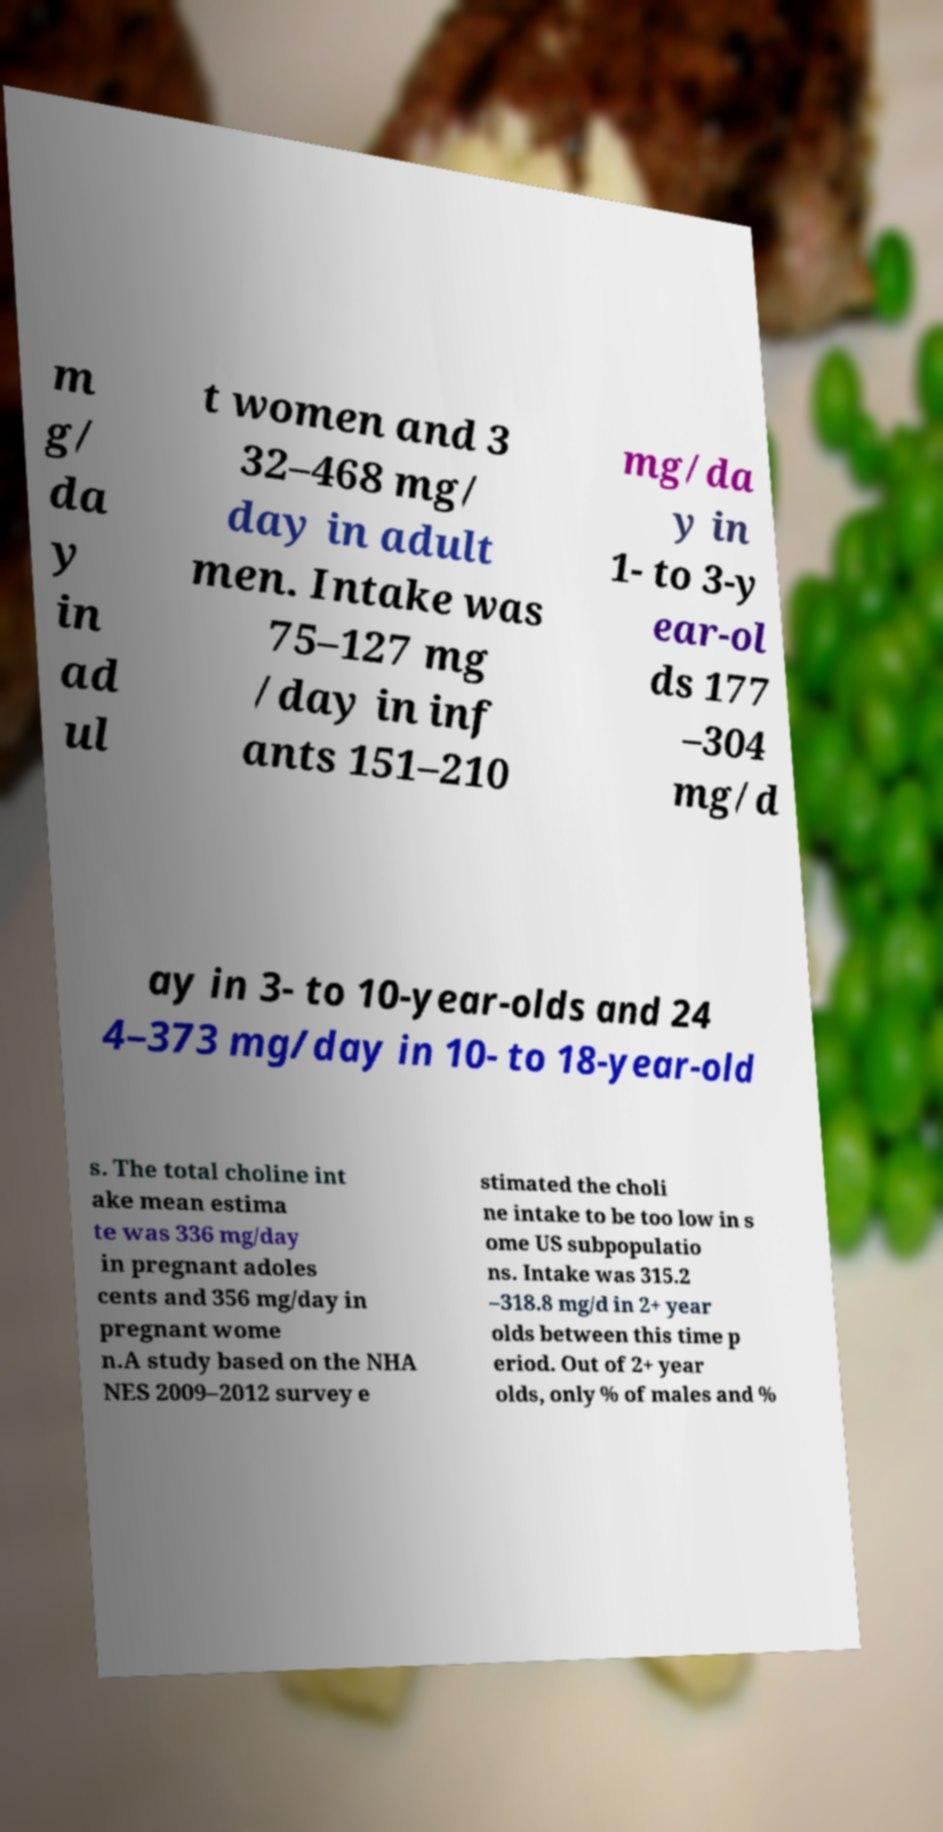For documentation purposes, I need the text within this image transcribed. Could you provide that? m g/ da y in ad ul t women and 3 32–468 mg/ day in adult men. Intake was 75–127 mg /day in inf ants 151–210 mg/da y in 1- to 3-y ear-ol ds 177 –304 mg/d ay in 3- to 10-year-olds and 24 4–373 mg/day in 10- to 18-year-old s. The total choline int ake mean estima te was 336 mg/day in pregnant adoles cents and 356 mg/day in pregnant wome n.A study based on the NHA NES 2009–2012 survey e stimated the choli ne intake to be too low in s ome US subpopulatio ns. Intake was 315.2 –318.8 mg/d in 2+ year olds between this time p eriod. Out of 2+ year olds, only % of males and % 